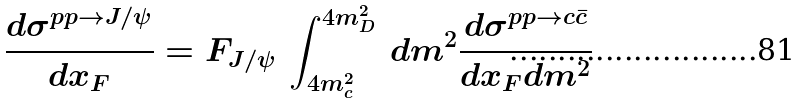Convert formula to latex. <formula><loc_0><loc_0><loc_500><loc_500>\frac { d \sigma ^ { p p \rightarrow J / \psi } } { d x _ { F } } = F _ { J / \psi } \, \int _ { 4 m _ { c } ^ { 2 } } ^ { 4 m _ { D } ^ { 2 } } \, d m ^ { 2 } \frac { d \sigma ^ { p p \rightarrow c \bar { c } } } { d x _ { F } d m ^ { 2 } }</formula> 